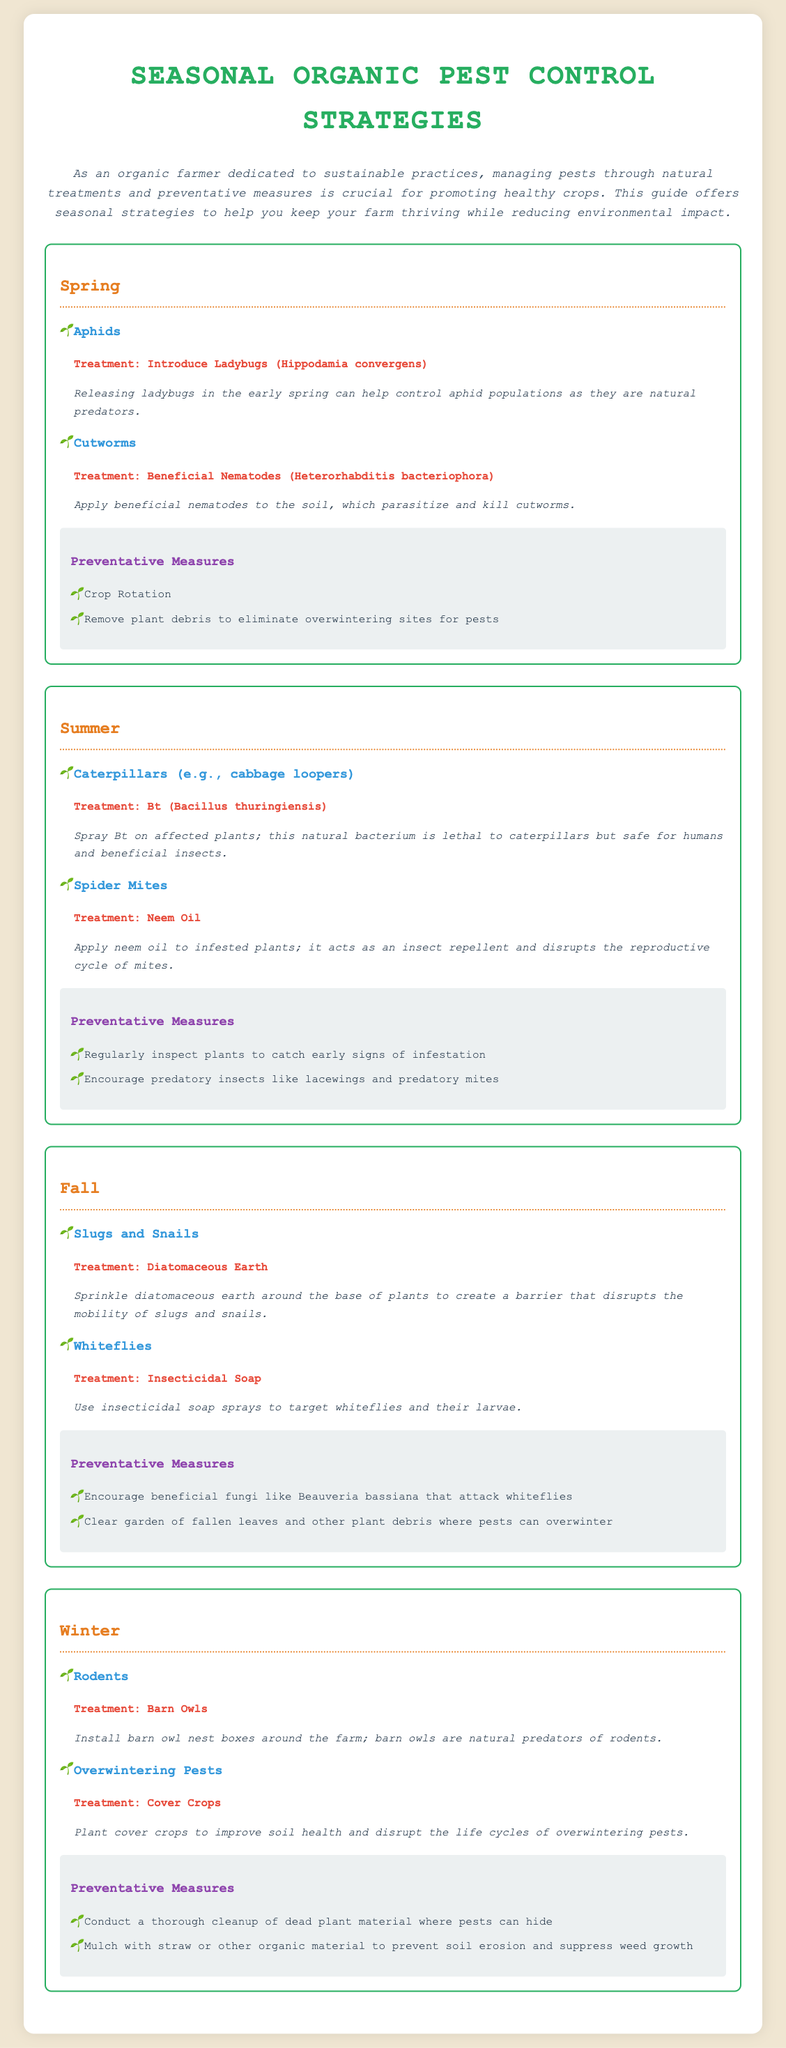What pest is treated with Ladybugs? Ladybugs are introduced to control aphids as mentioned in the Spring section.
Answer: Aphids What treatment is recommended for cutworms? The document states to apply beneficial nematodes to the soil for cutworms in the Spring section.
Answer: Beneficial Nematodes What is one preventative measure for Summer? The document lists regular inspections as a preventative measure against pests in the Summer section.
Answer: Regularly inspect plants What natural treatment is suggested for slugs and snails? Diatomaceous earth is sprinkled around plants as a treatment for slugs and snails in the Fall section.
Answer: Diatomaceous Earth Which natural predator helps control rodents in Winter? The document mentions installing barn owl nest boxes to control rodents naturally in the Winter section.
Answer: Barn Owls What is a treatment for Spider Mites? Neem oil is recommended as a treatment for spider mites in the Summer section.
Answer: Neem Oil What is a preventative measure mentioned for Fall? Clearing the garden of fallen leaves is suggested to prevent pests in Fall.
Answer: Clear garden of fallen leaves Which crop strategy is highlighted for Winter? The document advises planting cover crops to improve soil health and disrupt pest life cycles in Winter.
Answer: Cover Crops 